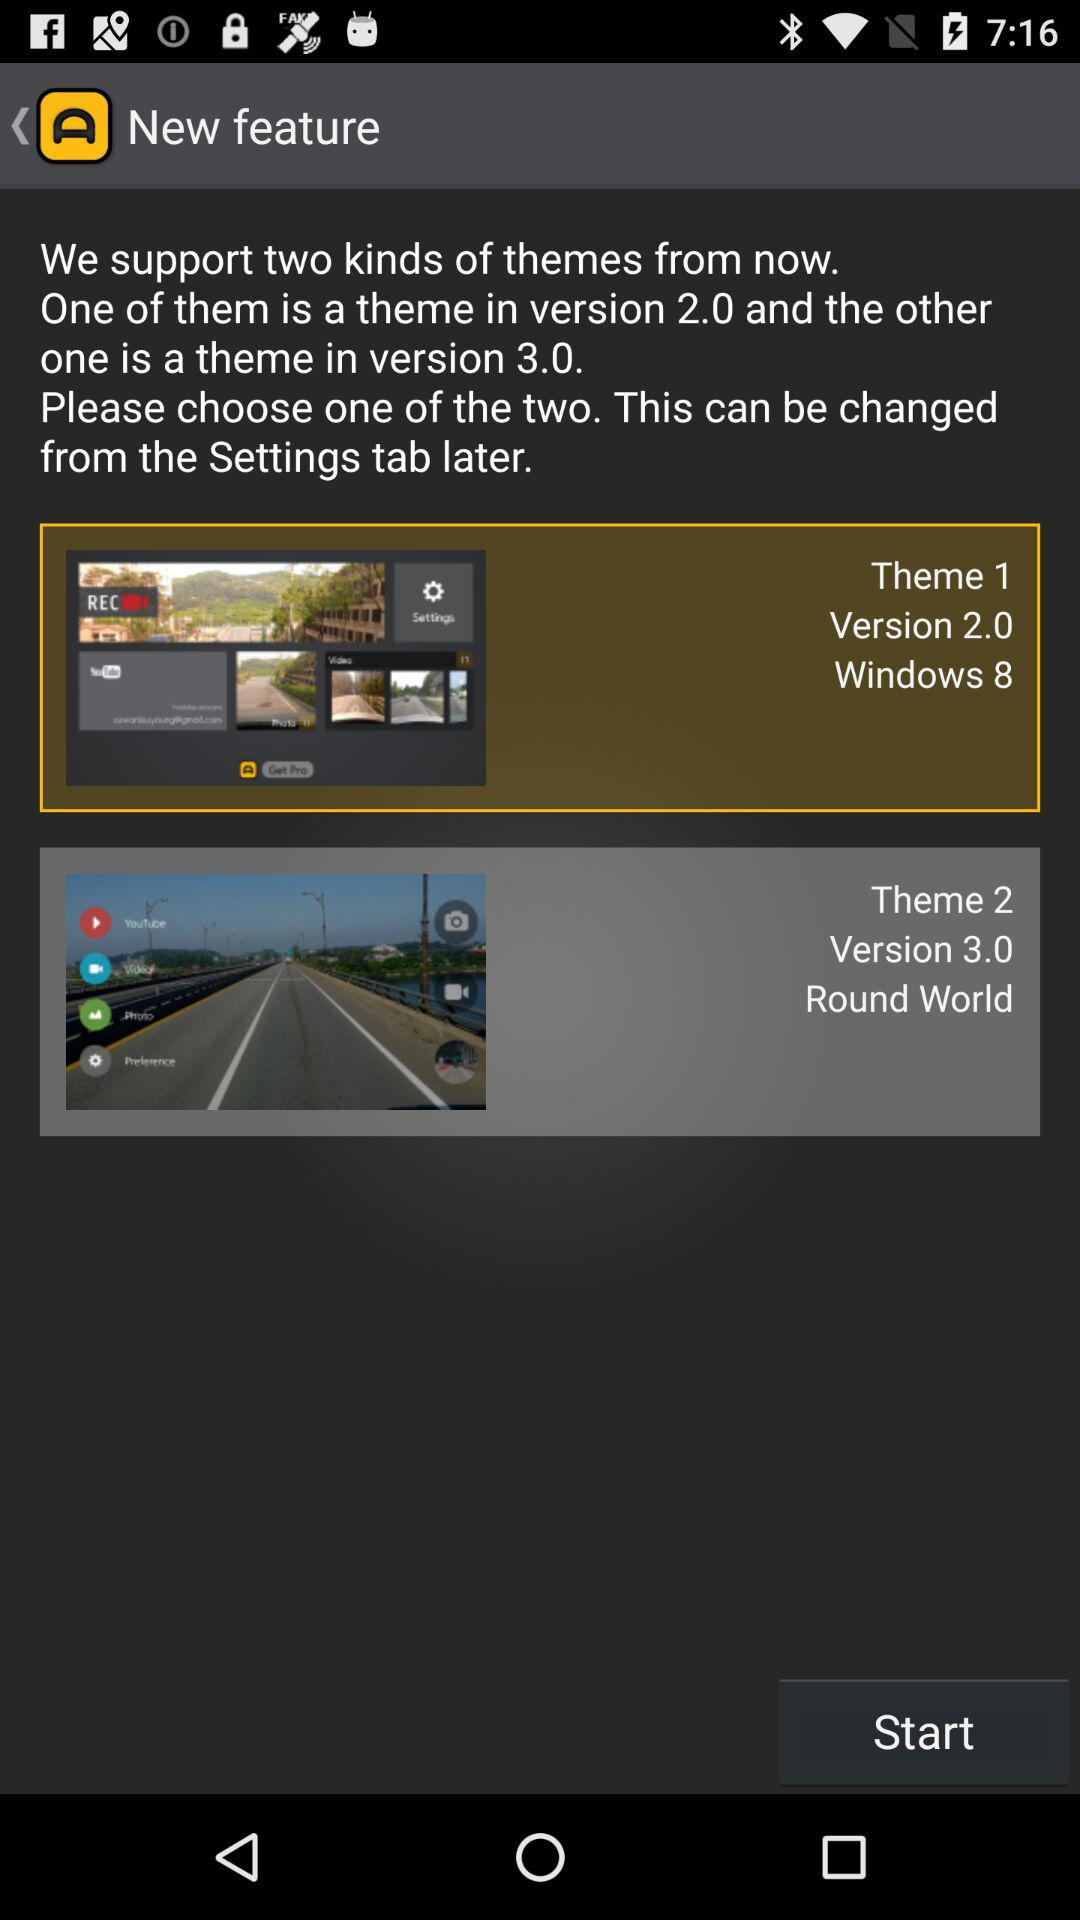What are the different versions of the theme? The different versions of the theme are 2.0 and 3.0. 